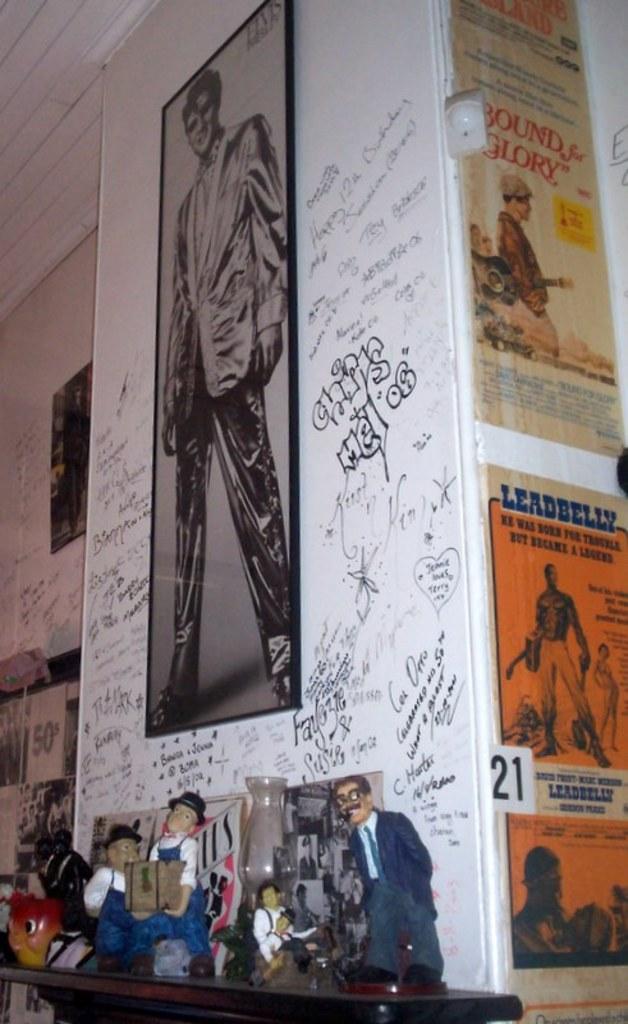What kind of belly is mentioned on the right side?
Your response must be concise. Leadbelly. What number is on the wall?
Ensure brevity in your answer.  21. 